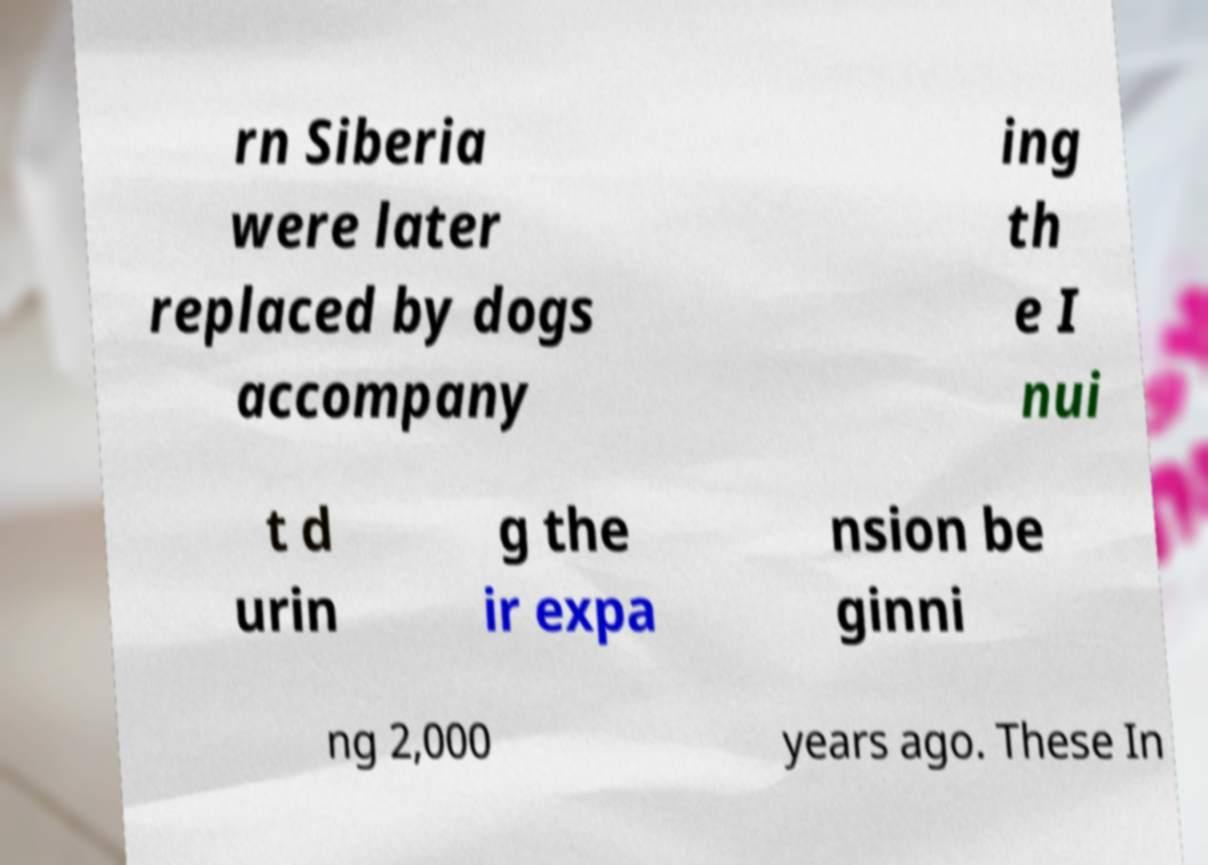What messages or text are displayed in this image? I need them in a readable, typed format. rn Siberia were later replaced by dogs accompany ing th e I nui t d urin g the ir expa nsion be ginni ng 2,000 years ago. These In 